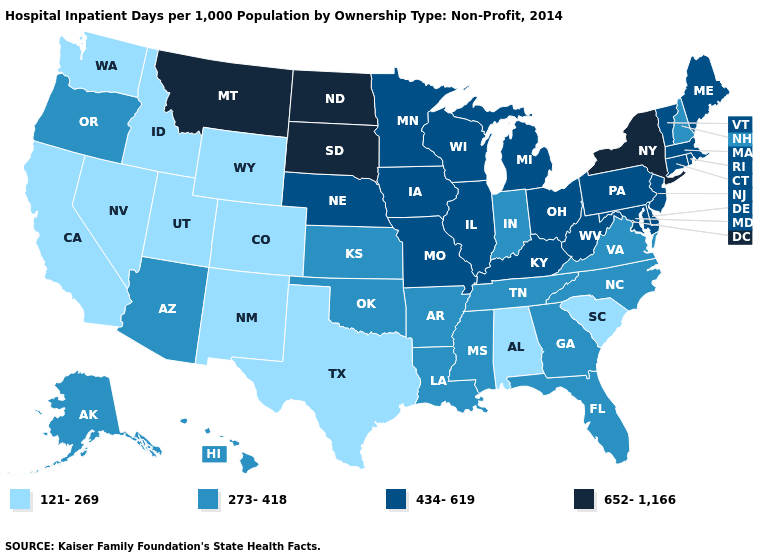Name the states that have a value in the range 121-269?
Answer briefly. Alabama, California, Colorado, Idaho, Nevada, New Mexico, South Carolina, Texas, Utah, Washington, Wyoming. What is the value of Wisconsin?
Keep it brief. 434-619. What is the value of Iowa?
Concise answer only. 434-619. What is the value of Arkansas?
Write a very short answer. 273-418. Does Tennessee have the same value as South Carolina?
Be succinct. No. Name the states that have a value in the range 273-418?
Answer briefly. Alaska, Arizona, Arkansas, Florida, Georgia, Hawaii, Indiana, Kansas, Louisiana, Mississippi, New Hampshire, North Carolina, Oklahoma, Oregon, Tennessee, Virginia. What is the value of New York?
Write a very short answer. 652-1,166. Among the states that border Alabama , which have the highest value?
Give a very brief answer. Florida, Georgia, Mississippi, Tennessee. What is the value of Idaho?
Quick response, please. 121-269. What is the lowest value in states that border Washington?
Quick response, please. 121-269. Which states have the lowest value in the USA?
Quick response, please. Alabama, California, Colorado, Idaho, Nevada, New Mexico, South Carolina, Texas, Utah, Washington, Wyoming. What is the value of Alabama?
Keep it brief. 121-269. Among the states that border Iowa , which have the highest value?
Concise answer only. South Dakota. How many symbols are there in the legend?
Give a very brief answer. 4. How many symbols are there in the legend?
Write a very short answer. 4. 